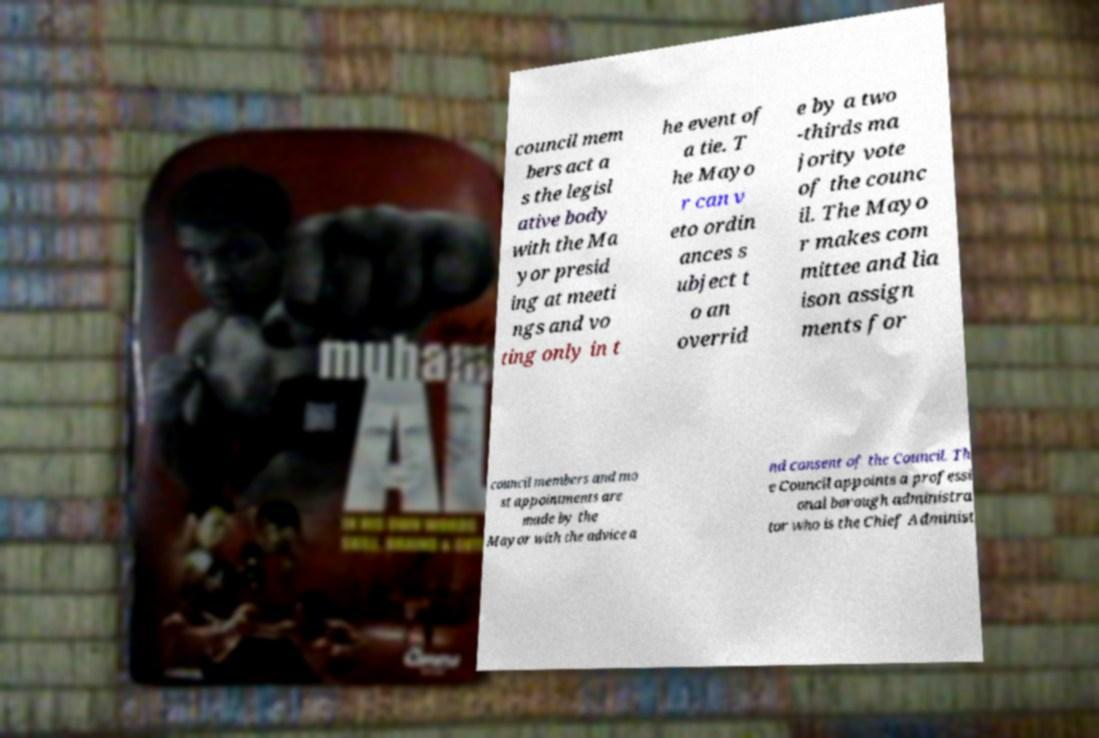Could you extract and type out the text from this image? council mem bers act a s the legisl ative body with the Ma yor presid ing at meeti ngs and vo ting only in t he event of a tie. T he Mayo r can v eto ordin ances s ubject t o an overrid e by a two -thirds ma jority vote of the counc il. The Mayo r makes com mittee and lia ison assign ments for council members and mo st appointments are made by the Mayor with the advice a nd consent of the Council. Th e Council appoints a professi onal borough administra tor who is the Chief Administ 